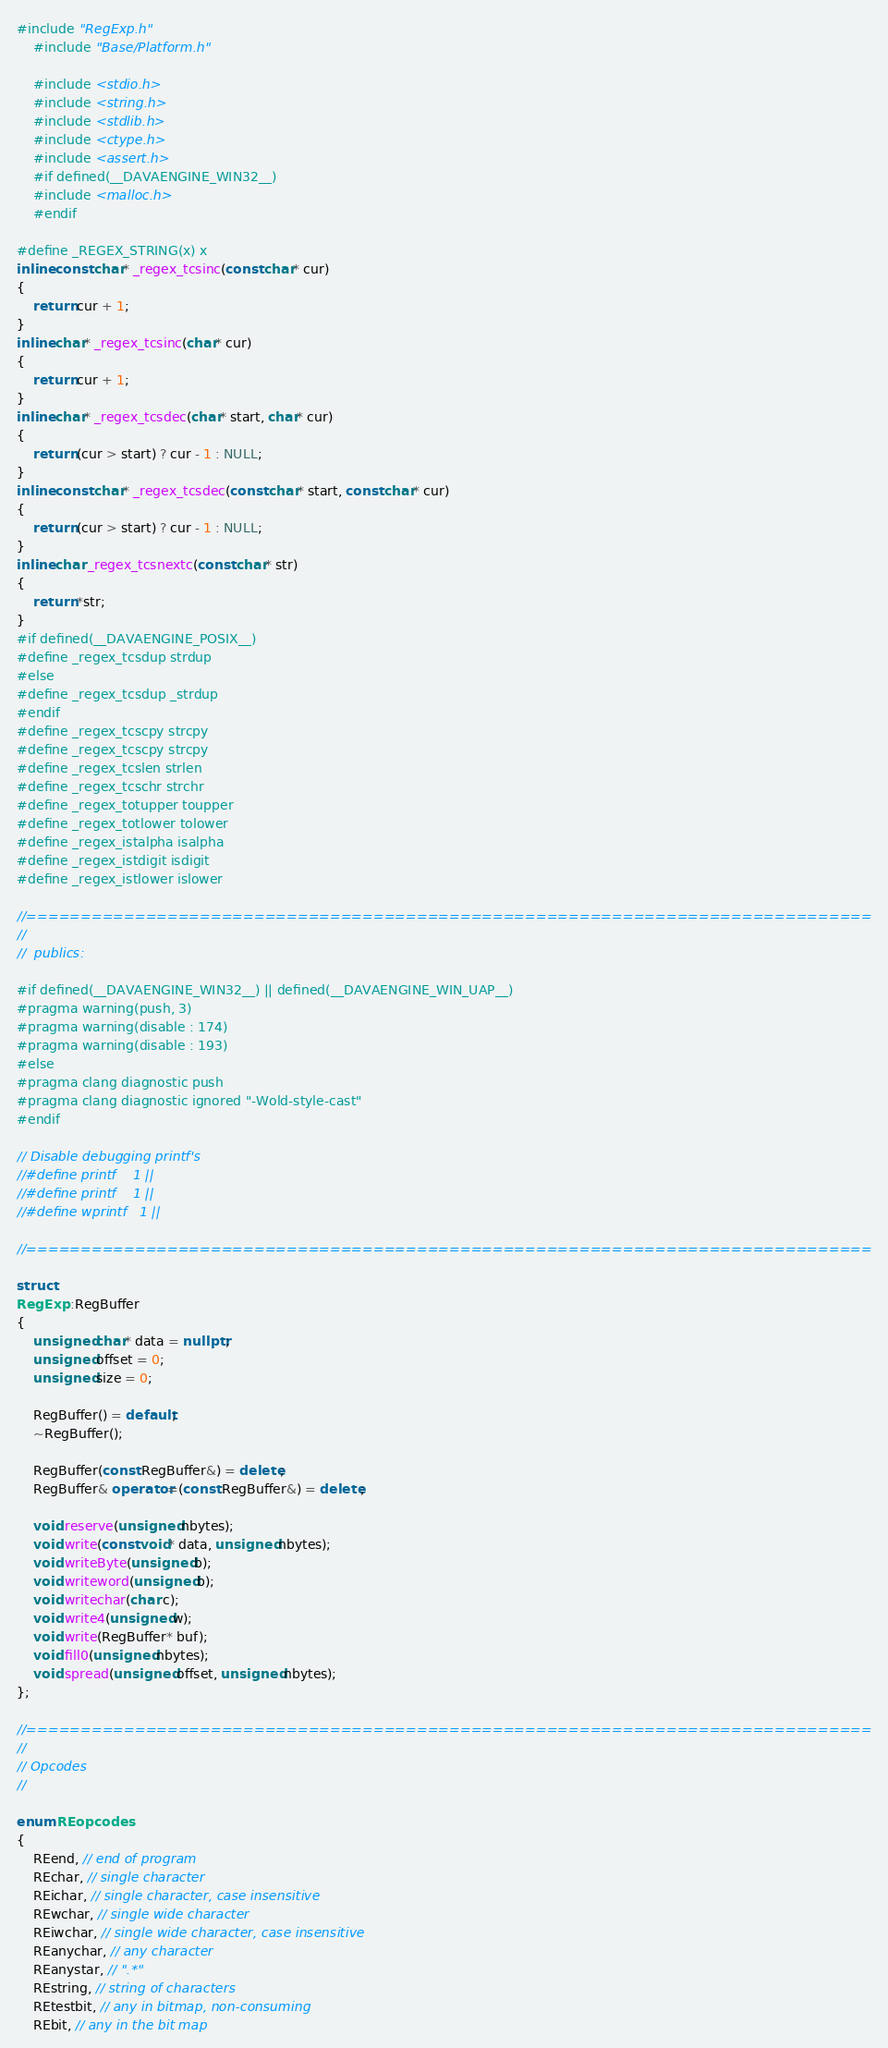<code> <loc_0><loc_0><loc_500><loc_500><_C++_>#include "RegExp.h"
    #include "Base/Platform.h"    

    #include <stdio.h>
    #include <string.h>
    #include <stdlib.h>
    #include <ctype.h>
    #include <assert.h>
    #if defined(__DAVAENGINE_WIN32__)
    #include <malloc.h>
    #endif

#define _REGEX_STRING(x) x
inline const char* _regex_tcsinc(const char* cur)
{
    return cur + 1;
}
inline char* _regex_tcsinc(char* cur)
{
    return cur + 1;
}
inline char* _regex_tcsdec(char* start, char* cur)
{
    return (cur > start) ? cur - 1 : NULL;
}
inline const char* _regex_tcsdec(const char* start, const char* cur)
{
    return (cur > start) ? cur - 1 : NULL;
}
inline char _regex_tcsnextc(const char* str)
{
    return *str;
}
#if defined(__DAVAENGINE_POSIX__)
#define _regex_tcsdup strdup
#else
#define _regex_tcsdup _strdup
#endif
#define _regex_tcscpy strcpy
#define _regex_tcscpy strcpy
#define _regex_tcslen strlen
#define _regex_tcschr strchr
#define _regex_totupper toupper
#define _regex_totlower tolower
#define _regex_istalpha isalpha
#define _regex_istdigit isdigit
#define _regex_istlower islower

//==============================================================================
//
//  publics:

#if defined(__DAVAENGINE_WIN32__) || defined(__DAVAENGINE_WIN_UAP__)
#pragma warning(push, 3)
#pragma warning(disable : 174)
#pragma warning(disable : 193)
#else
#pragma clang diagnostic push
#pragma clang diagnostic ignored "-Wold-style-cast"
#endif

// Disable debugging printf's
//#define printf    1 ||
//#define printf    1 ||
//#define wprintf   1 ||

//==============================================================================

struct
RegExp::RegBuffer
{
    unsigned char* data = nullptr;
    unsigned offset = 0;
    unsigned size = 0;

    RegBuffer() = default;
    ~RegBuffer();

    RegBuffer(const RegBuffer&) = delete;
    RegBuffer& operator=(const RegBuffer&) = delete;

    void reserve(unsigned nbytes);
    void write(const void* data, unsigned nbytes);
    void writeByte(unsigned b);
    void writeword(unsigned b);
    void writechar(char c);
    void write4(unsigned w);
    void write(RegBuffer* buf);
    void fill0(unsigned nbytes);
    void spread(unsigned offset, unsigned nbytes);
};

//==============================================================================
//
// Opcodes
//

enum REopcodes
{
    REend, // end of program
    REchar, // single character
    REichar, // single character, case insensitive
    REwchar, // single wide character
    REiwchar, // single wide character, case insensitive
    REanychar, // any character
    REanystar, // ".*"
    REstring, // string of characters
    REtestbit, // any in bitmap, non-consuming
    REbit, // any in the bit map</code> 